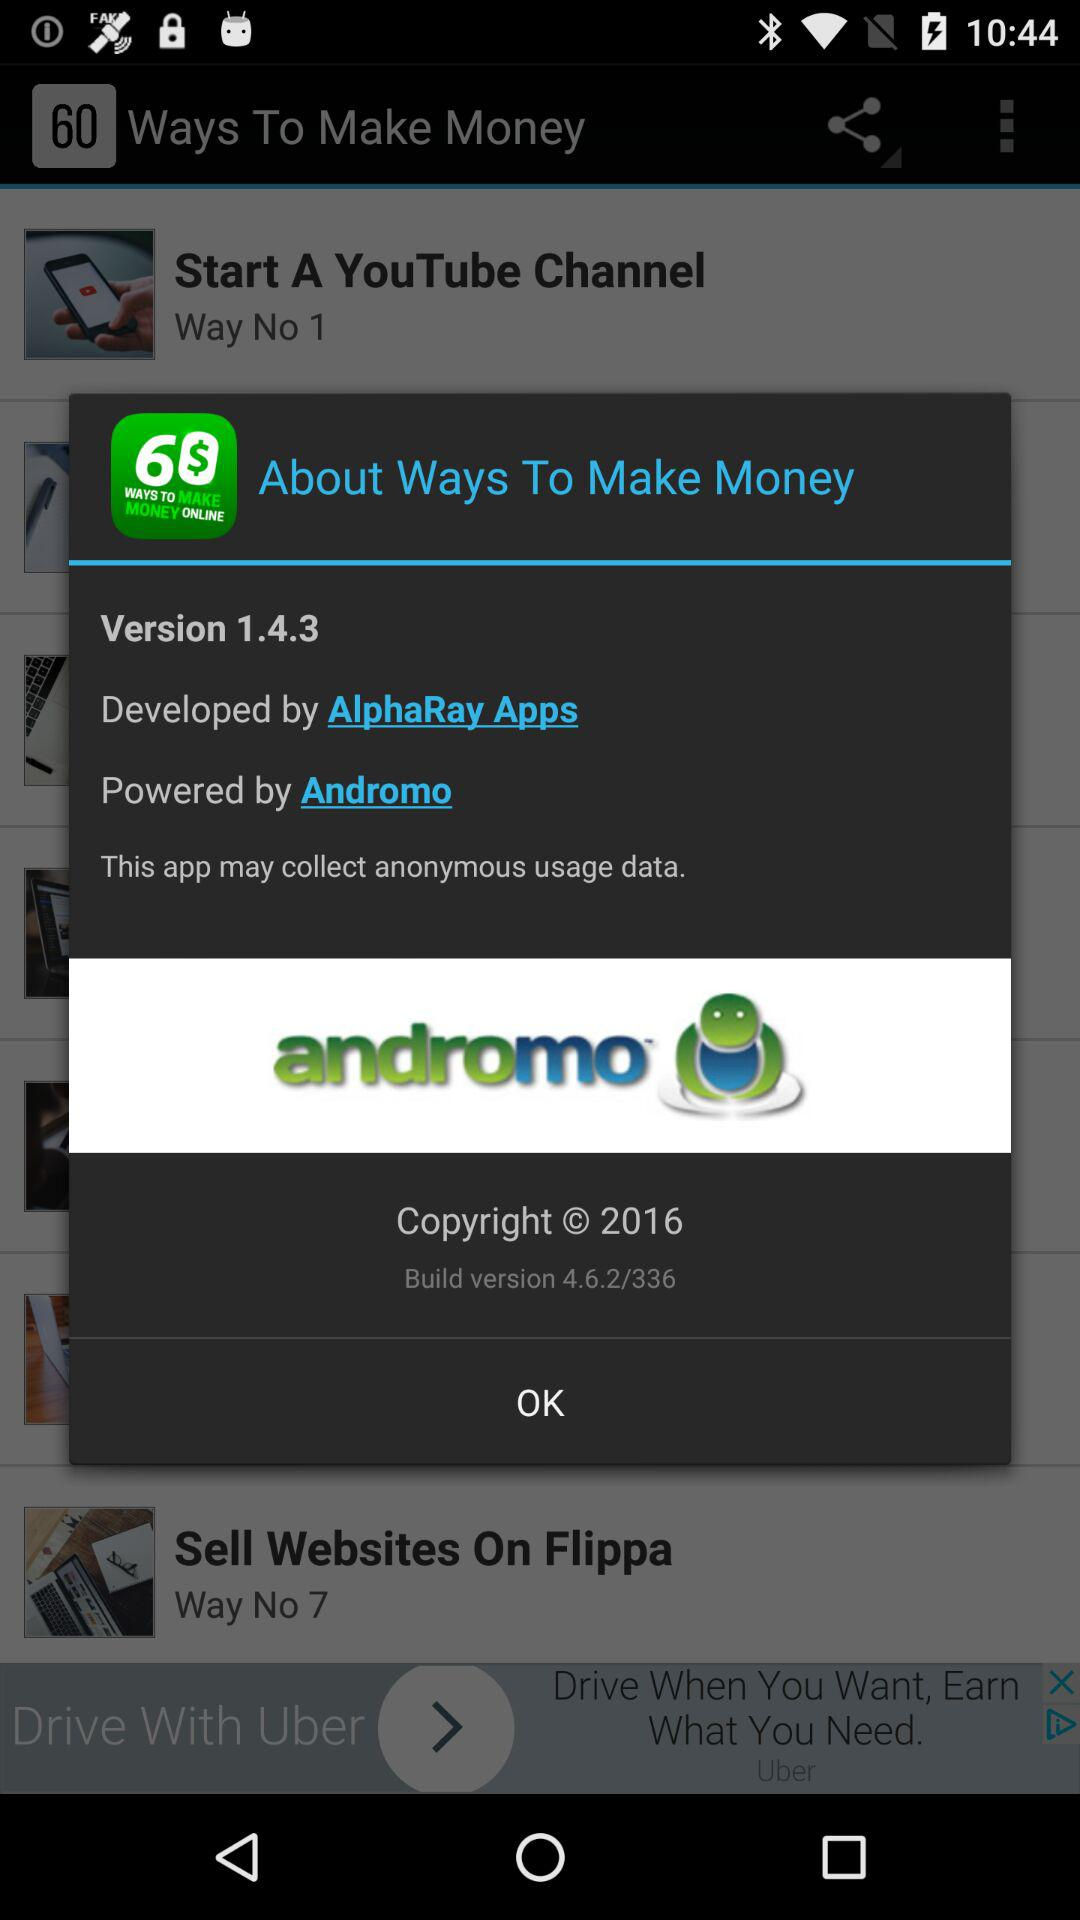What is the app title? The app title is "60 WAYS TO MAKE MONEY ONLINE". 